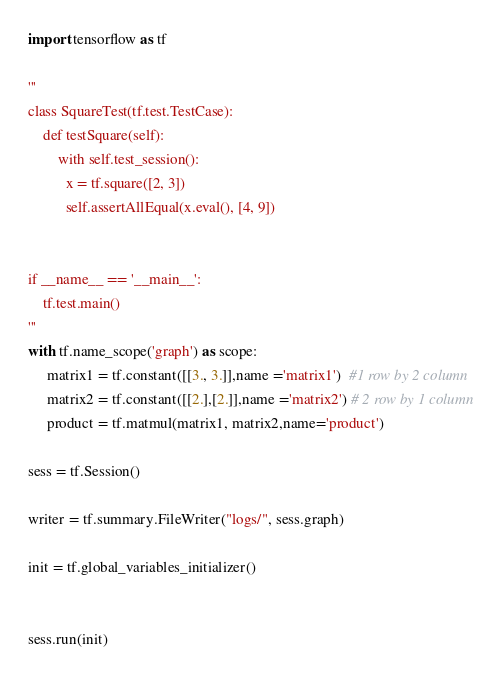Convert code to text. <code><loc_0><loc_0><loc_500><loc_500><_Python_>import tensorflow as tf

'''
class SquareTest(tf.test.TestCase):
    def testSquare(self):
        with self.test_session():
          x = tf.square([2, 3])
          self.assertAllEqual(x.eval(), [4, 9])


if __name__ == '__main__':
    tf.test.main()
'''
with tf.name_scope('graph') as scope:
     matrix1 = tf.constant([[3., 3.]],name ='matrix1')  #1 row by 2 column
     matrix2 = tf.constant([[2.],[2.]],name ='matrix2') # 2 row by 1 column
     product = tf.matmul(matrix1, matrix2,name='product')
  
sess = tf.Session()

writer = tf.summary.FileWriter("logs/", sess.graph)

init = tf.global_variables_initializer()


sess.run(init)</code> 